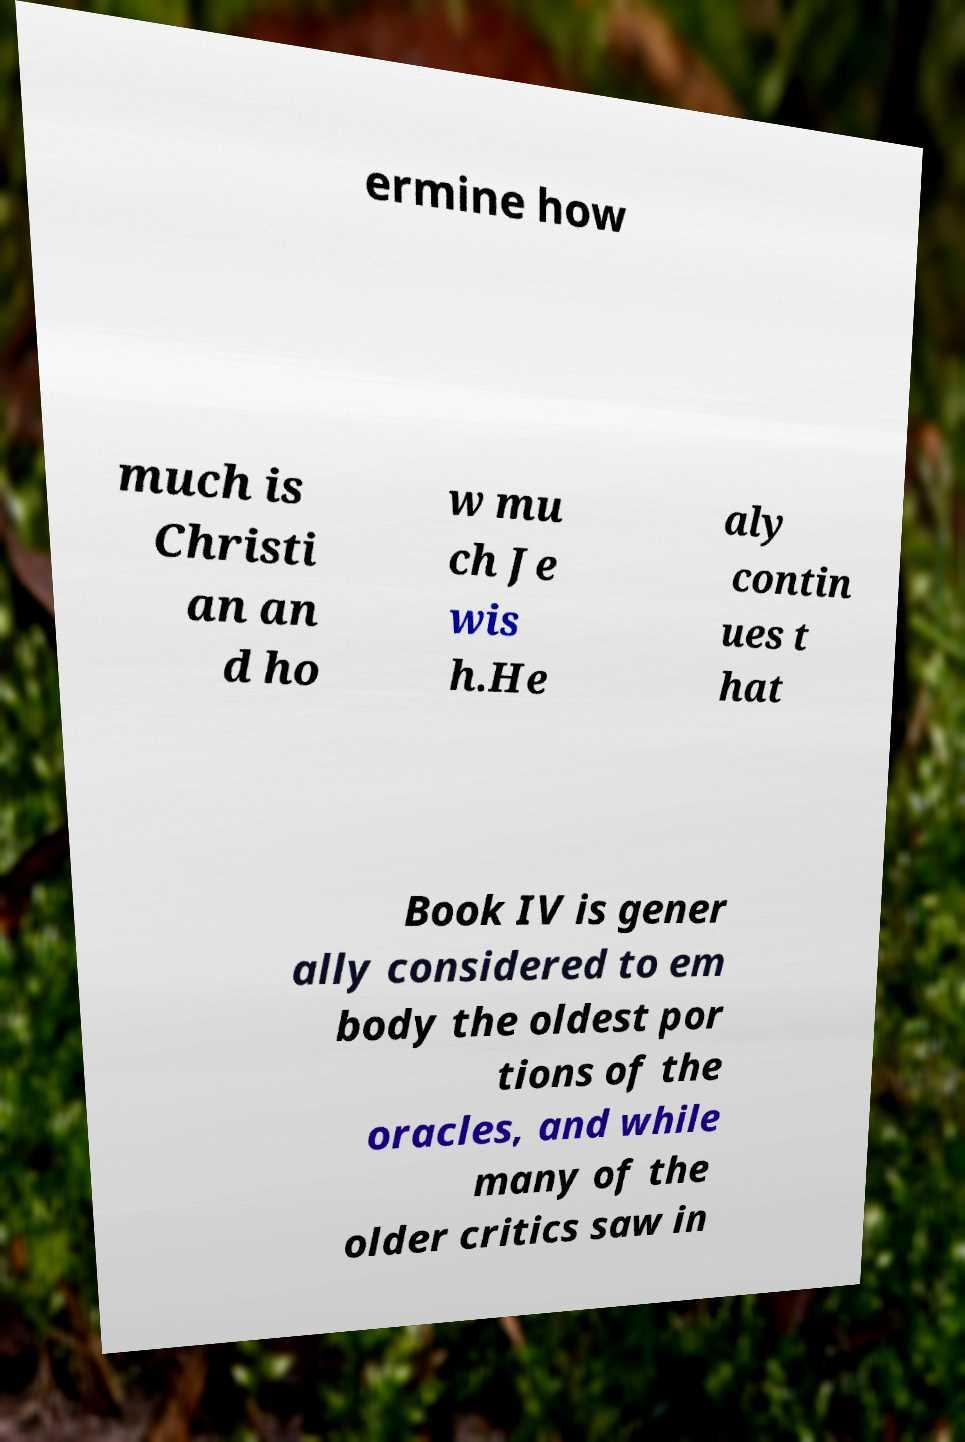For documentation purposes, I need the text within this image transcribed. Could you provide that? ermine how much is Christi an an d ho w mu ch Je wis h.He aly contin ues t hat Book IV is gener ally considered to em body the oldest por tions of the oracles, and while many of the older critics saw in 